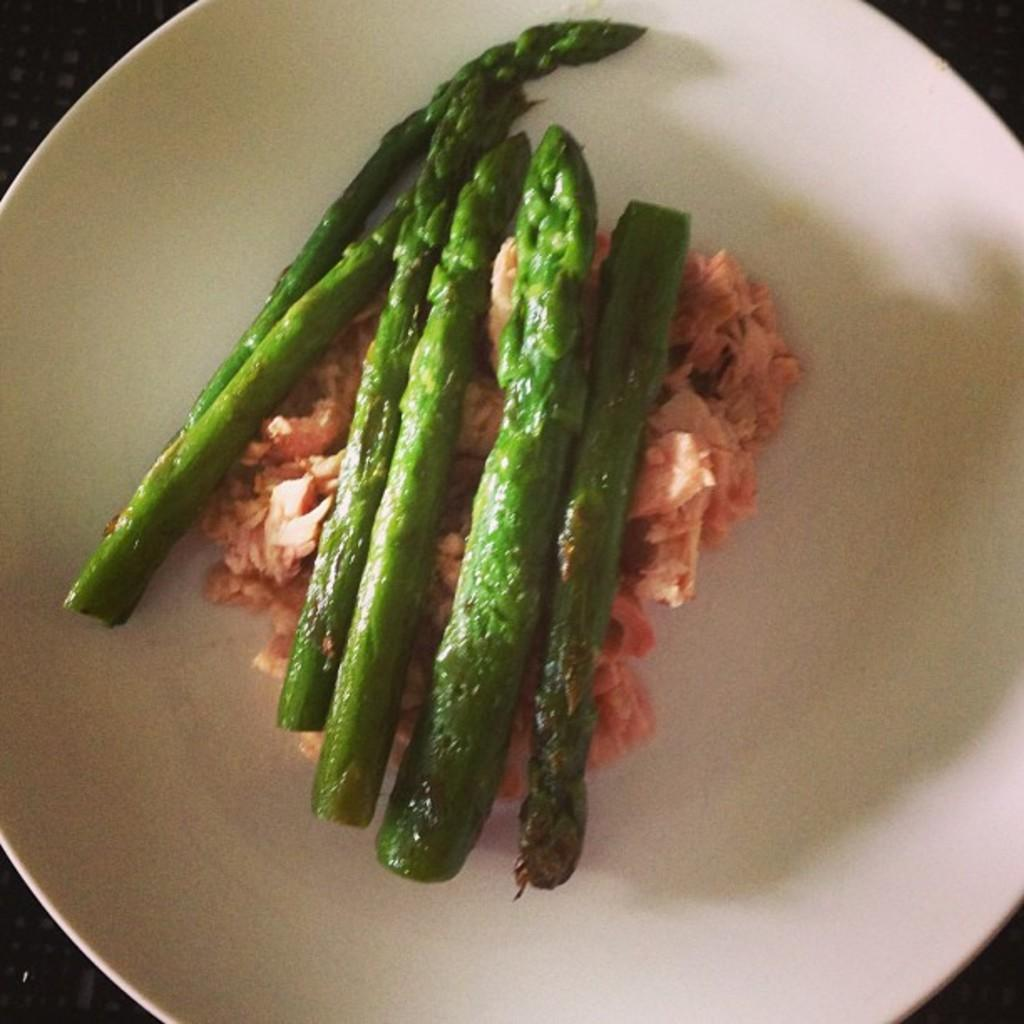What is the color of the surface in the image? The surface in the image is black colored. What is placed on the surface? There is a white colored plate on the surface. What is on the plate? The plate contains a food item that is green and pink in color. Can you see the sand blowing in the image? There is no sand or blowing action present in the image. Is there a cook preparing the food in the image? The image does not show any cooking or cook preparing the food. 